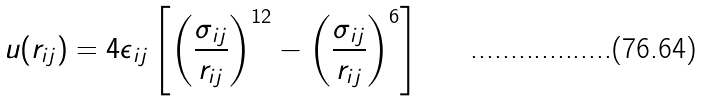<formula> <loc_0><loc_0><loc_500><loc_500>u ( r _ { i j } ) = 4 \epsilon _ { i j } \left [ \left ( \frac { \sigma _ { i j } } { r _ { i j } } \right ) ^ { 1 2 } - \left ( \frac { \sigma _ { i j } } { r _ { i j } } \right ) ^ { 6 } \right ]</formula> 